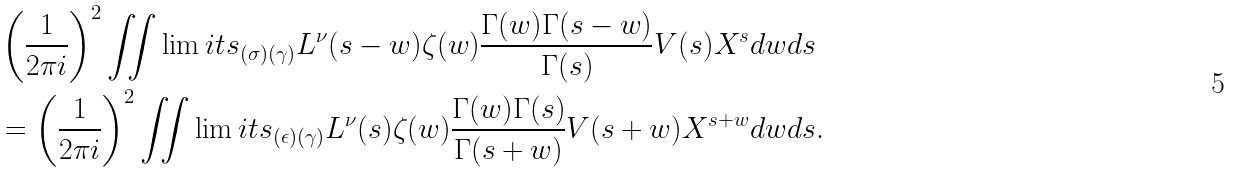<formula> <loc_0><loc_0><loc_500><loc_500>& \left ( \frac { 1 } { 2 \pi i } \right ) ^ { 2 } \iint \lim i t s _ { ( \sigma ) ( \gamma ) } L ^ { \nu } ( s - w ) \zeta ( w ) \frac { \Gamma ( w ) \Gamma ( s - w ) } { \Gamma ( s ) } V ( s ) X ^ { s } d w d s \\ & = \left ( \frac { 1 } { 2 \pi i } \right ) ^ { 2 } \iint \lim i t s _ { ( \epsilon ) ( \gamma ) } L ^ { \nu } ( s ) \zeta ( w ) \frac { \Gamma ( w ) \Gamma ( s ) } { \Gamma ( s + w ) } V ( s + w ) X ^ { s + w } d w d s .</formula> 